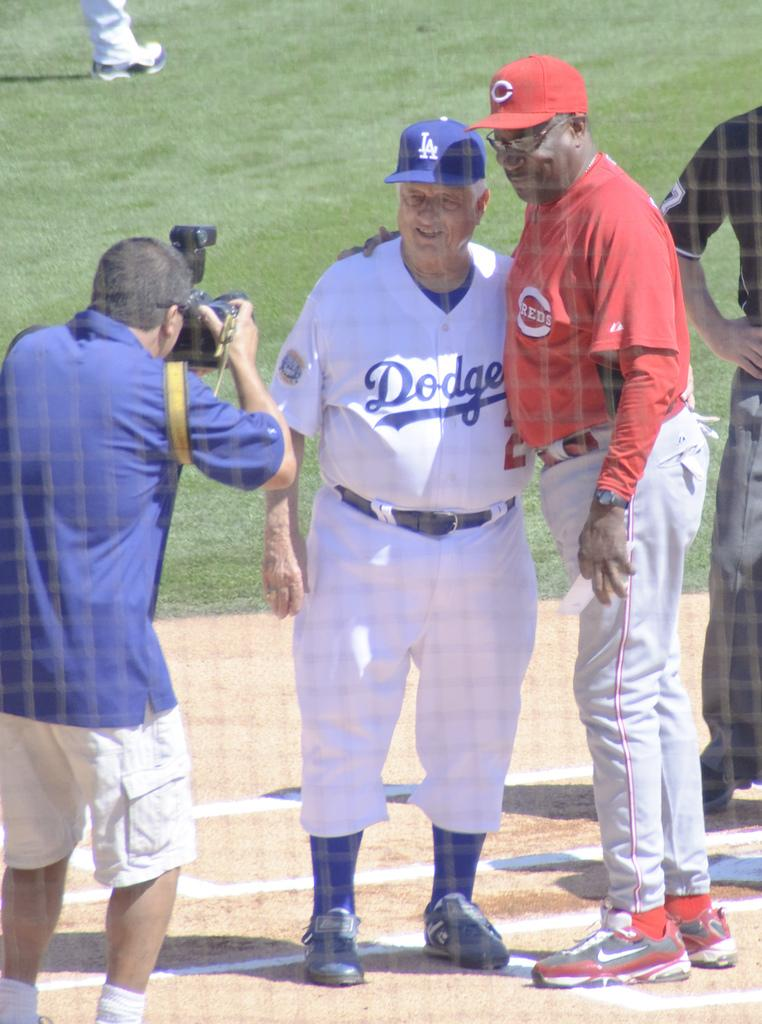Provide a one-sentence caption for the provided image. A photographer is taking a picture of two older men, a white man dressed in a Dodgers uniform and a black man in a Reds uniform. 